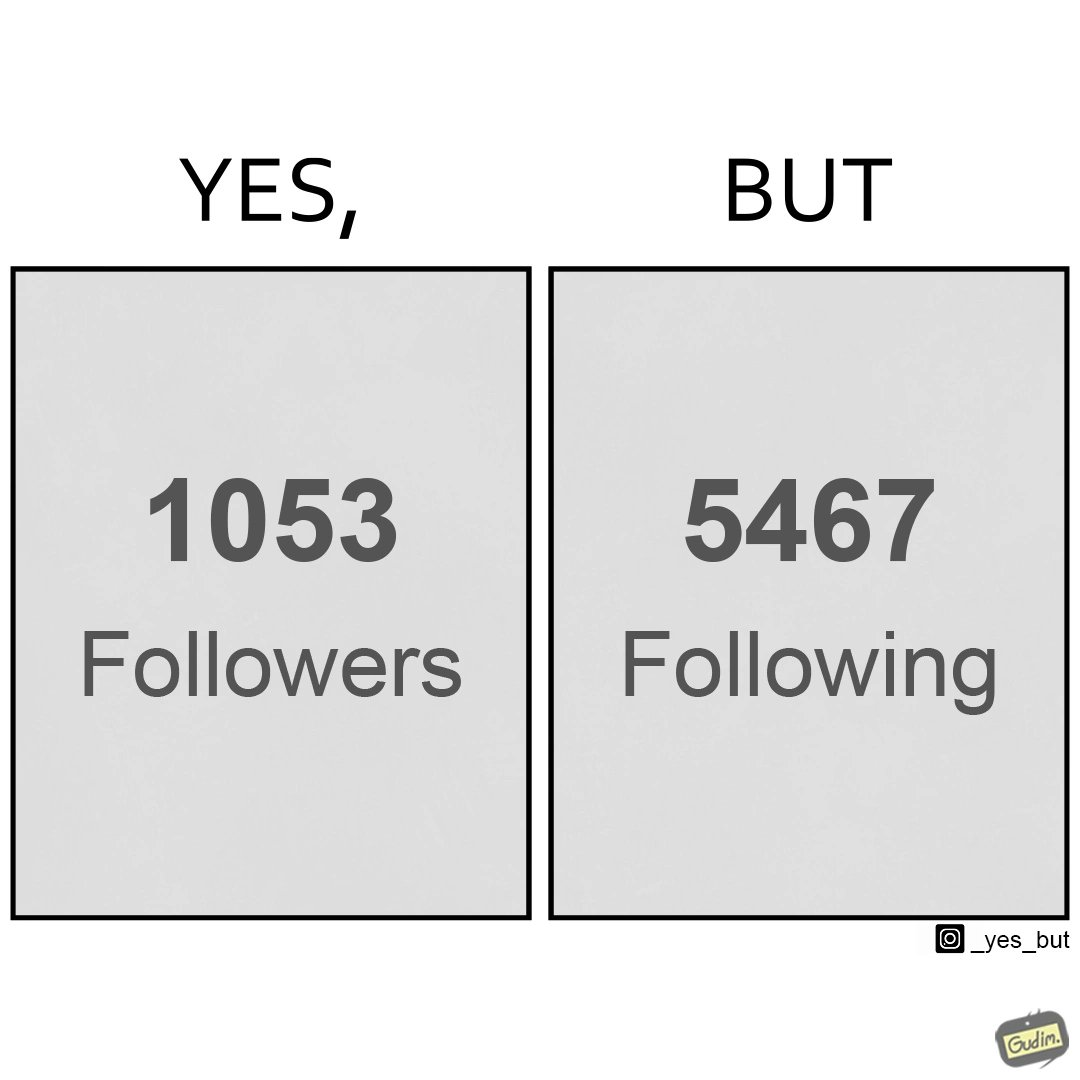What makes this image funny or satirical? The image creates a comparison between the following and followers of a account which suggests that the person/organizations follows more people/organizations than being followed back 